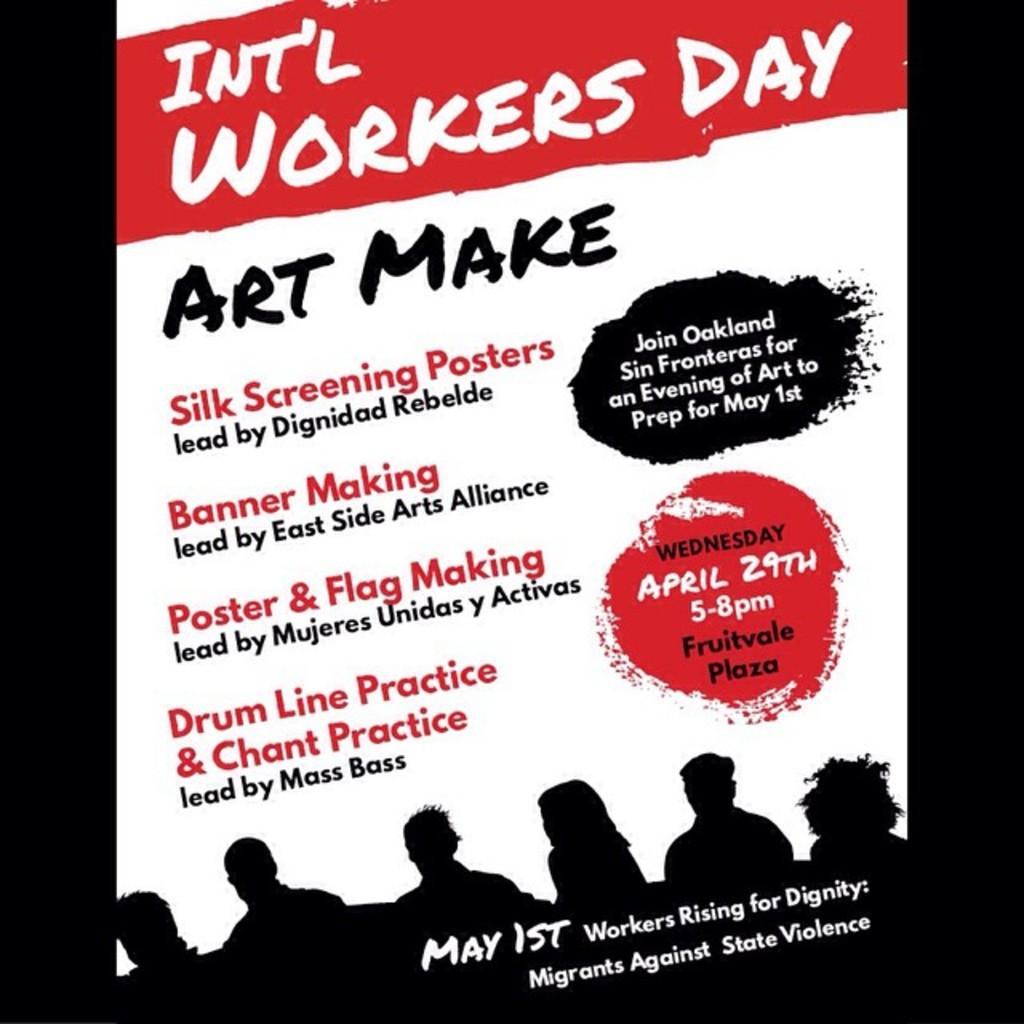Could you give a brief overview of what you see in this image? In this picture I see the poster on which there is something written and on the bottom of this picture I see depiction of persons. 